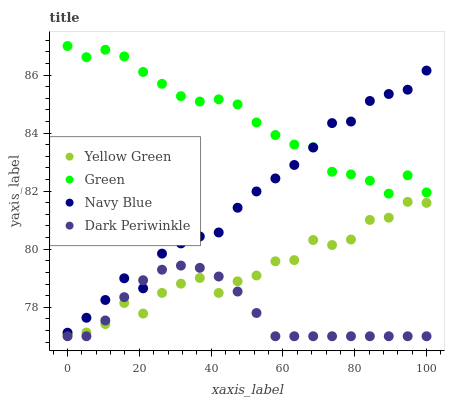Does Dark Periwinkle have the minimum area under the curve?
Answer yes or no. Yes. Does Green have the maximum area under the curve?
Answer yes or no. Yes. Does Yellow Green have the minimum area under the curve?
Answer yes or no. No. Does Yellow Green have the maximum area under the curve?
Answer yes or no. No. Is Dark Periwinkle the smoothest?
Answer yes or no. Yes. Is Yellow Green the roughest?
Answer yes or no. Yes. Is Green the smoothest?
Answer yes or no. No. Is Green the roughest?
Answer yes or no. No. Does Dark Periwinkle have the lowest value?
Answer yes or no. Yes. Does Yellow Green have the lowest value?
Answer yes or no. No. Does Green have the highest value?
Answer yes or no. Yes. Does Yellow Green have the highest value?
Answer yes or no. No. Is Yellow Green less than Navy Blue?
Answer yes or no. Yes. Is Green greater than Yellow Green?
Answer yes or no. Yes. Does Green intersect Navy Blue?
Answer yes or no. Yes. Is Green less than Navy Blue?
Answer yes or no. No. Is Green greater than Navy Blue?
Answer yes or no. No. Does Yellow Green intersect Navy Blue?
Answer yes or no. No. 